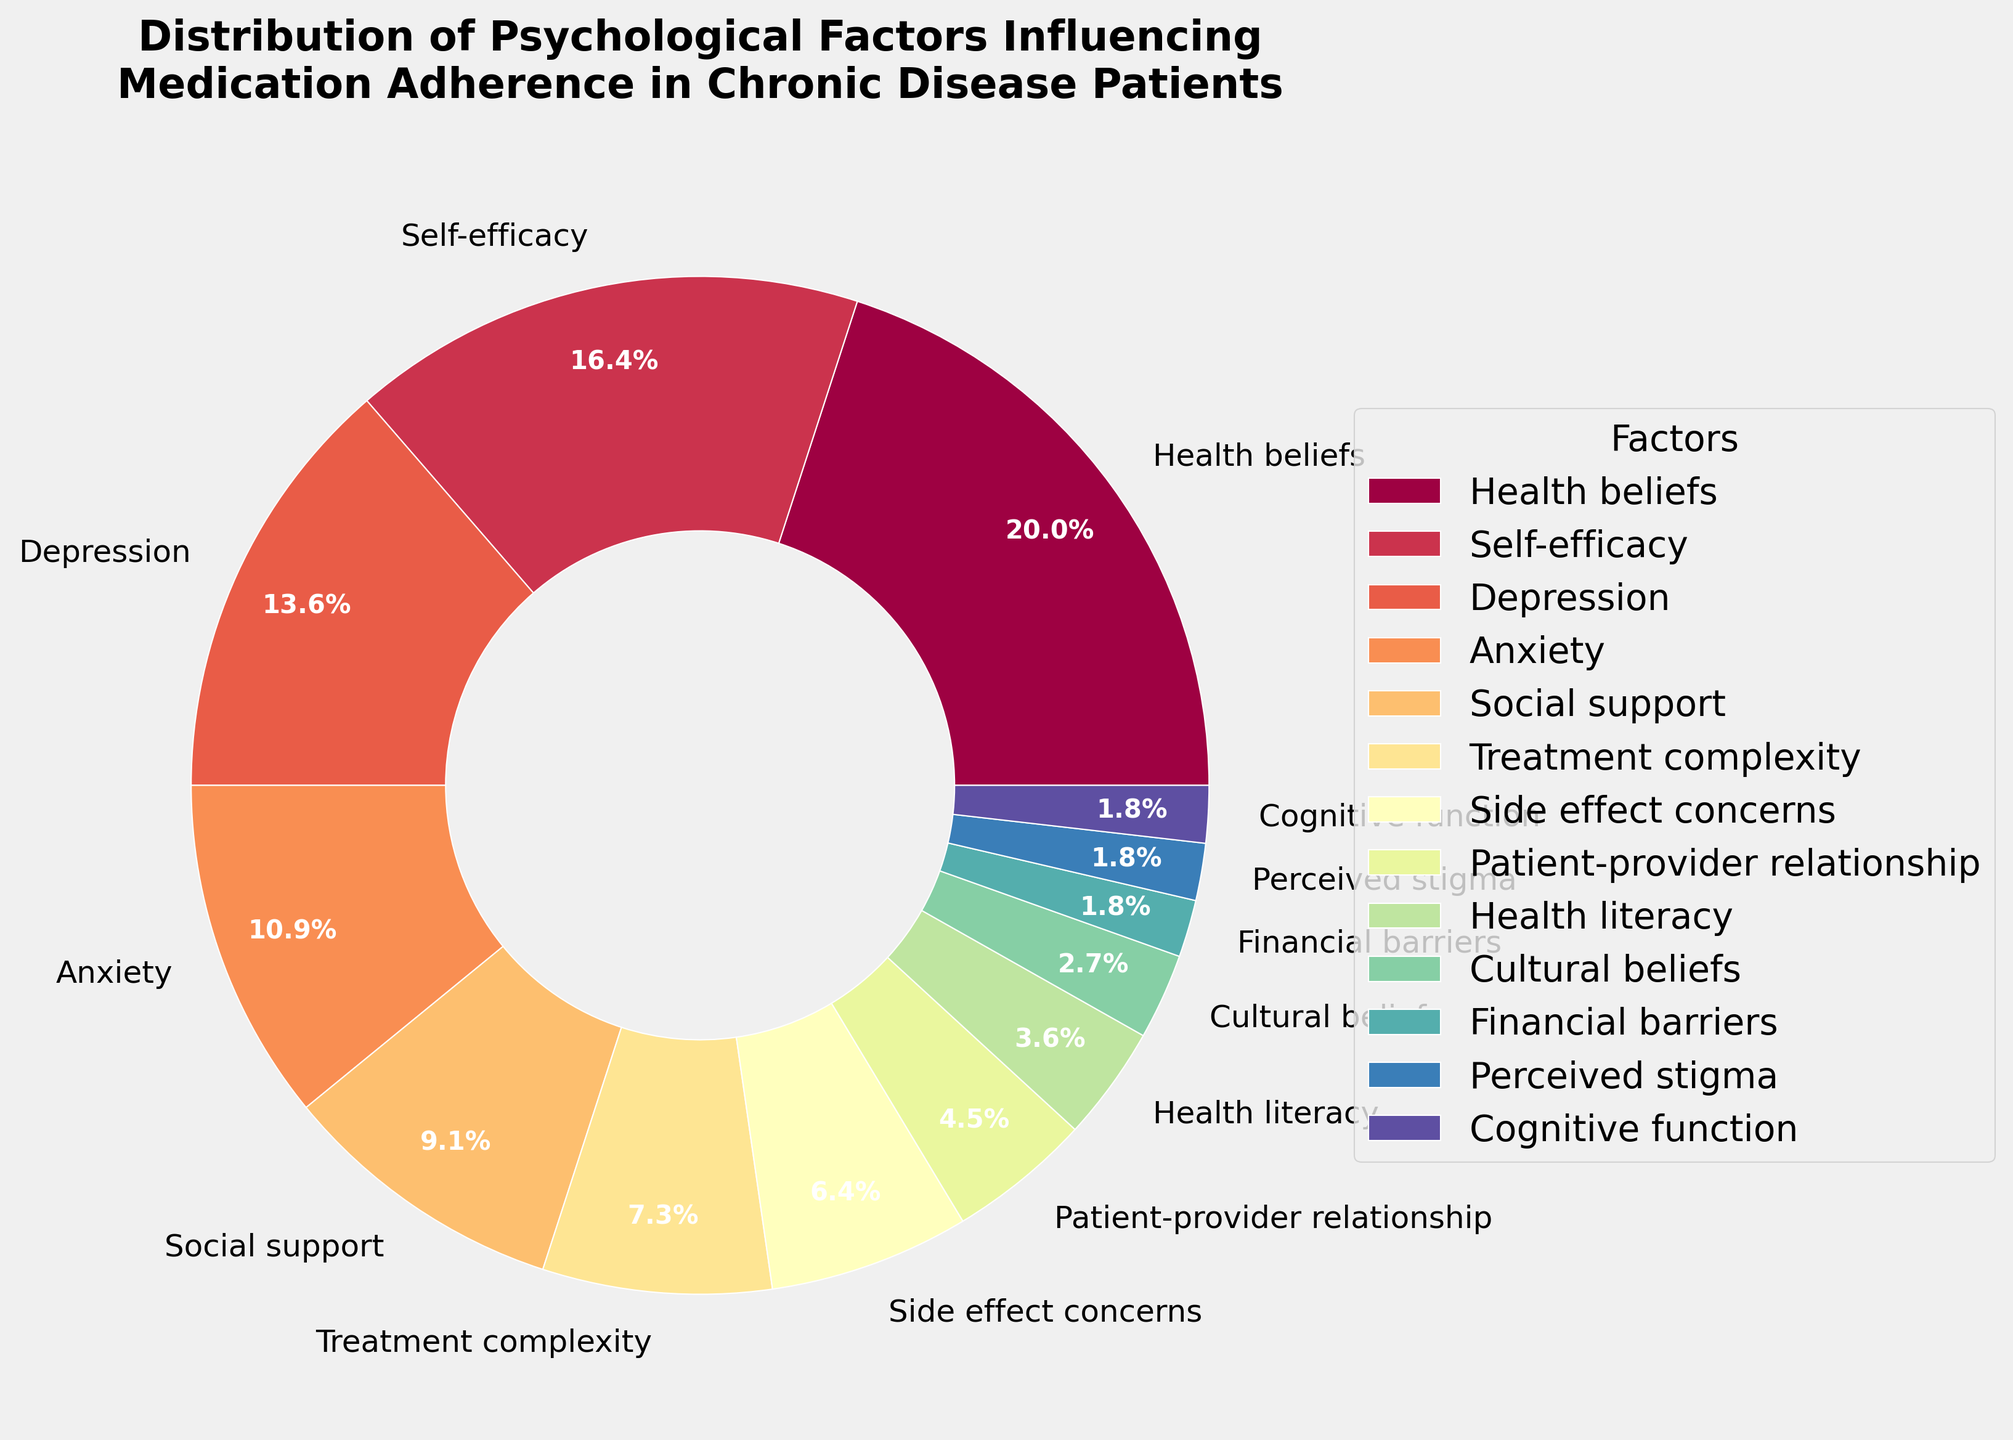What psychological factor has the highest percentage in the distribution? The pie chart shows that "Health beliefs" has the highest percentage, marked clearly by its larger wedge slice and label.
Answer: Health beliefs Which factors have the lowest percentage in the distribution? The pie chart shows that "Cognitive function," "Perceived stigma," and "Financial barriers" each have a wedge representing 2%, the smallest percentages.
Answer: Cognitive function, Perceived stigma, Financial barriers What is the total percentage of psychological factors related to mental health (Depression, Anxiety)? The percentages for "Depression" and "Anxiety" are 15% and 12% respectively. Adding them together gives 15 + 12 = 27%.
Answer: 27% Compare the percentage of "Health beliefs" to that of "Treatment complexity." How many times larger is "Health beliefs"? The percentage for "Health beliefs" is 22%, and for "Treatment complexity" it's 8%. Dividing these values gives 22 / 8 = 2.75, so "Health beliefs" is 2.75 times larger.
Answer: 2.75 times Which factor has a smaller percentage: "Side effect concerns" or "Social support"? The pie chart shows "Side effect concerns" at 7% and "Social support" at 10%. Therefore, "Side effect concerns" has the smaller percentage.
Answer: Side effect concerns What is the combined percentage of factors related to patient interaction with healthcare system ("Patient-provider relationship," "Health literacy")? The percentages for "Patient-provider relationship" and "Health literacy" are 5% and 4% respectively. Adding these together gives 5 + 4 = 9%.
Answer: 9% Identify the third largest psychological factor influencing medication adherence. The pie chart shows "Depression" as the third largest factor, following "Health beliefs" and "Self-efficacy" in size and percentage.
Answer: Depression Between "Self-efficacy" and "Anxiety," which factor has a higher percentage and by how much? The percentages for "Self-efficacy" and "Anxiety" are 18% and 12% respectively. The difference is 18 - 12 = 6%. Therefore, "Self-efficacy" has a higher percentage by 6%.
Answer: 6% What is the difference in percentage between "Social support" and "Treatment complexity"? The percentages for "Social support" and "Treatment complexity" are 10% and 8% respectively. The difference is 10 - 8 = 2%.
Answer: 2% Which factors, if combined, would total roughly one-third (approximately 33%) of the distribution? The combined percentages of "Anxiety" (12%), "Social support" (10%), and "Treatment complexity" (8%) are 12 + 10 + 8 = 30%, which is approximately one-third of the total distribution.
Answer: Anxiety, Social support, Treatment complexity 